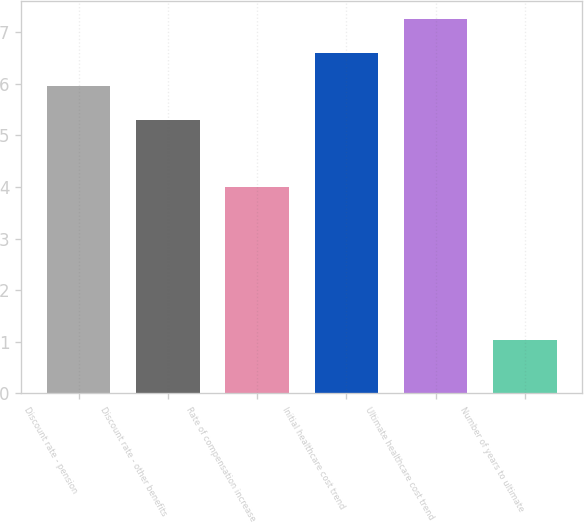<chart> <loc_0><loc_0><loc_500><loc_500><bar_chart><fcel>Discount rate - pension<fcel>Discount rate - other benefits<fcel>Rate of compensation increase<fcel>Initial healthcare cost trend<fcel>Ultimate healthcare cost trend<fcel>Number of years to ultimate<nl><fcel>5.95<fcel>5.3<fcel>4<fcel>6.6<fcel>7.25<fcel>1.04<nl></chart> 